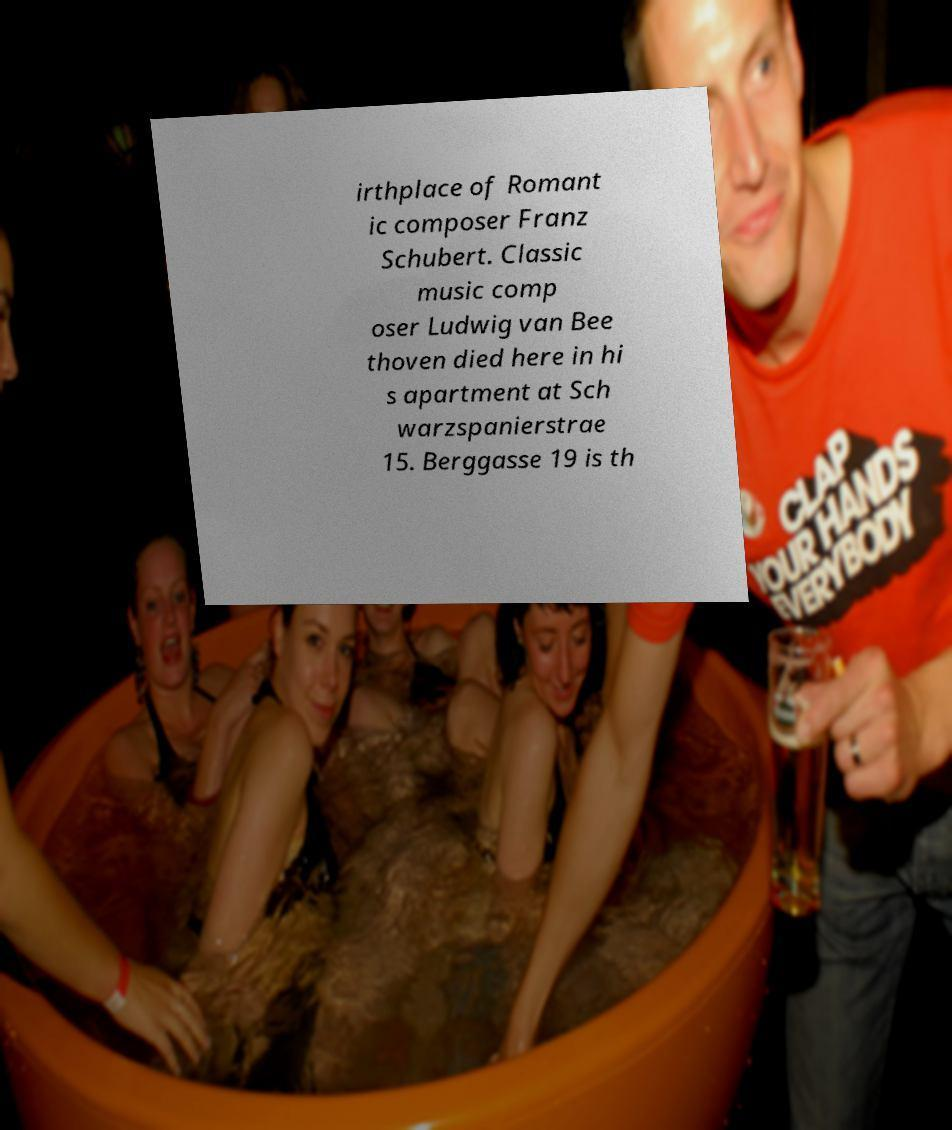Can you accurately transcribe the text from the provided image for me? irthplace of Romant ic composer Franz Schubert. Classic music comp oser Ludwig van Bee thoven died here in hi s apartment at Sch warzspanierstrae 15. Berggasse 19 is th 